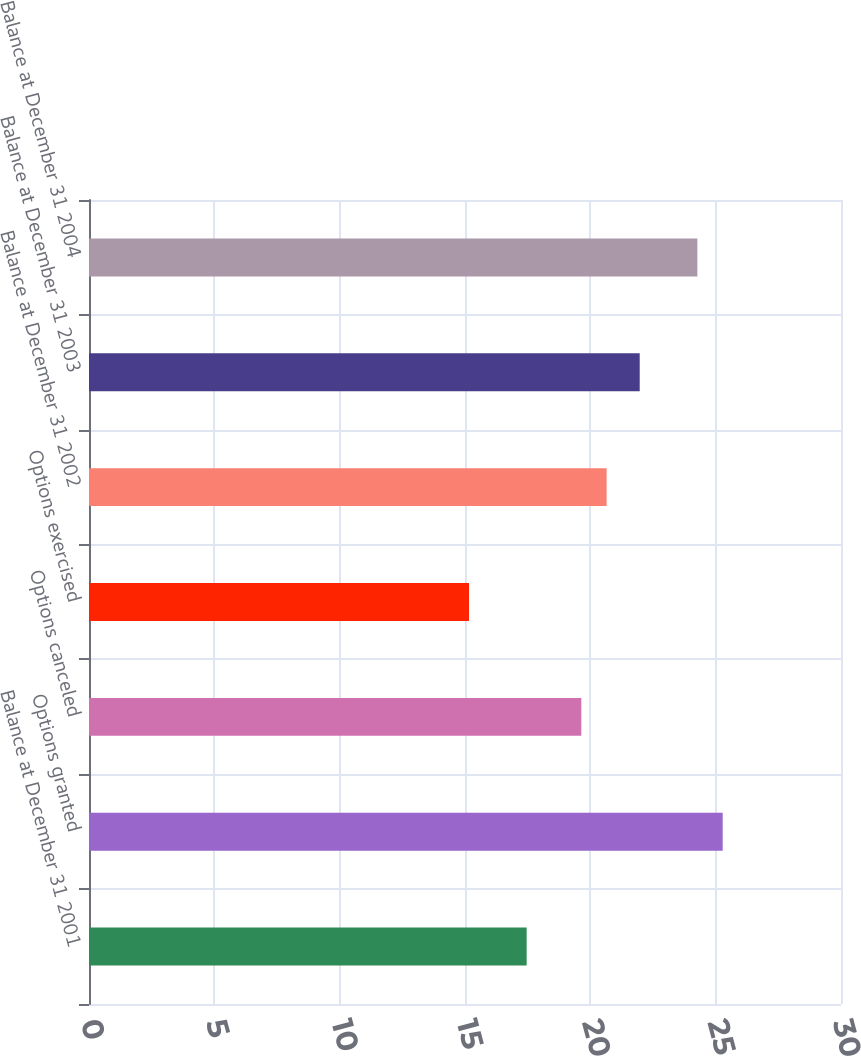Convert chart. <chart><loc_0><loc_0><loc_500><loc_500><bar_chart><fcel>Balance at December 31 2001<fcel>Options granted<fcel>Options canceled<fcel>Options exercised<fcel>Balance at December 31 2002<fcel>Balance at December 31 2003<fcel>Balance at December 31 2004<nl><fcel>17.46<fcel>25.28<fcel>19.64<fcel>15.16<fcel>20.65<fcel>21.97<fcel>24.27<nl></chart> 